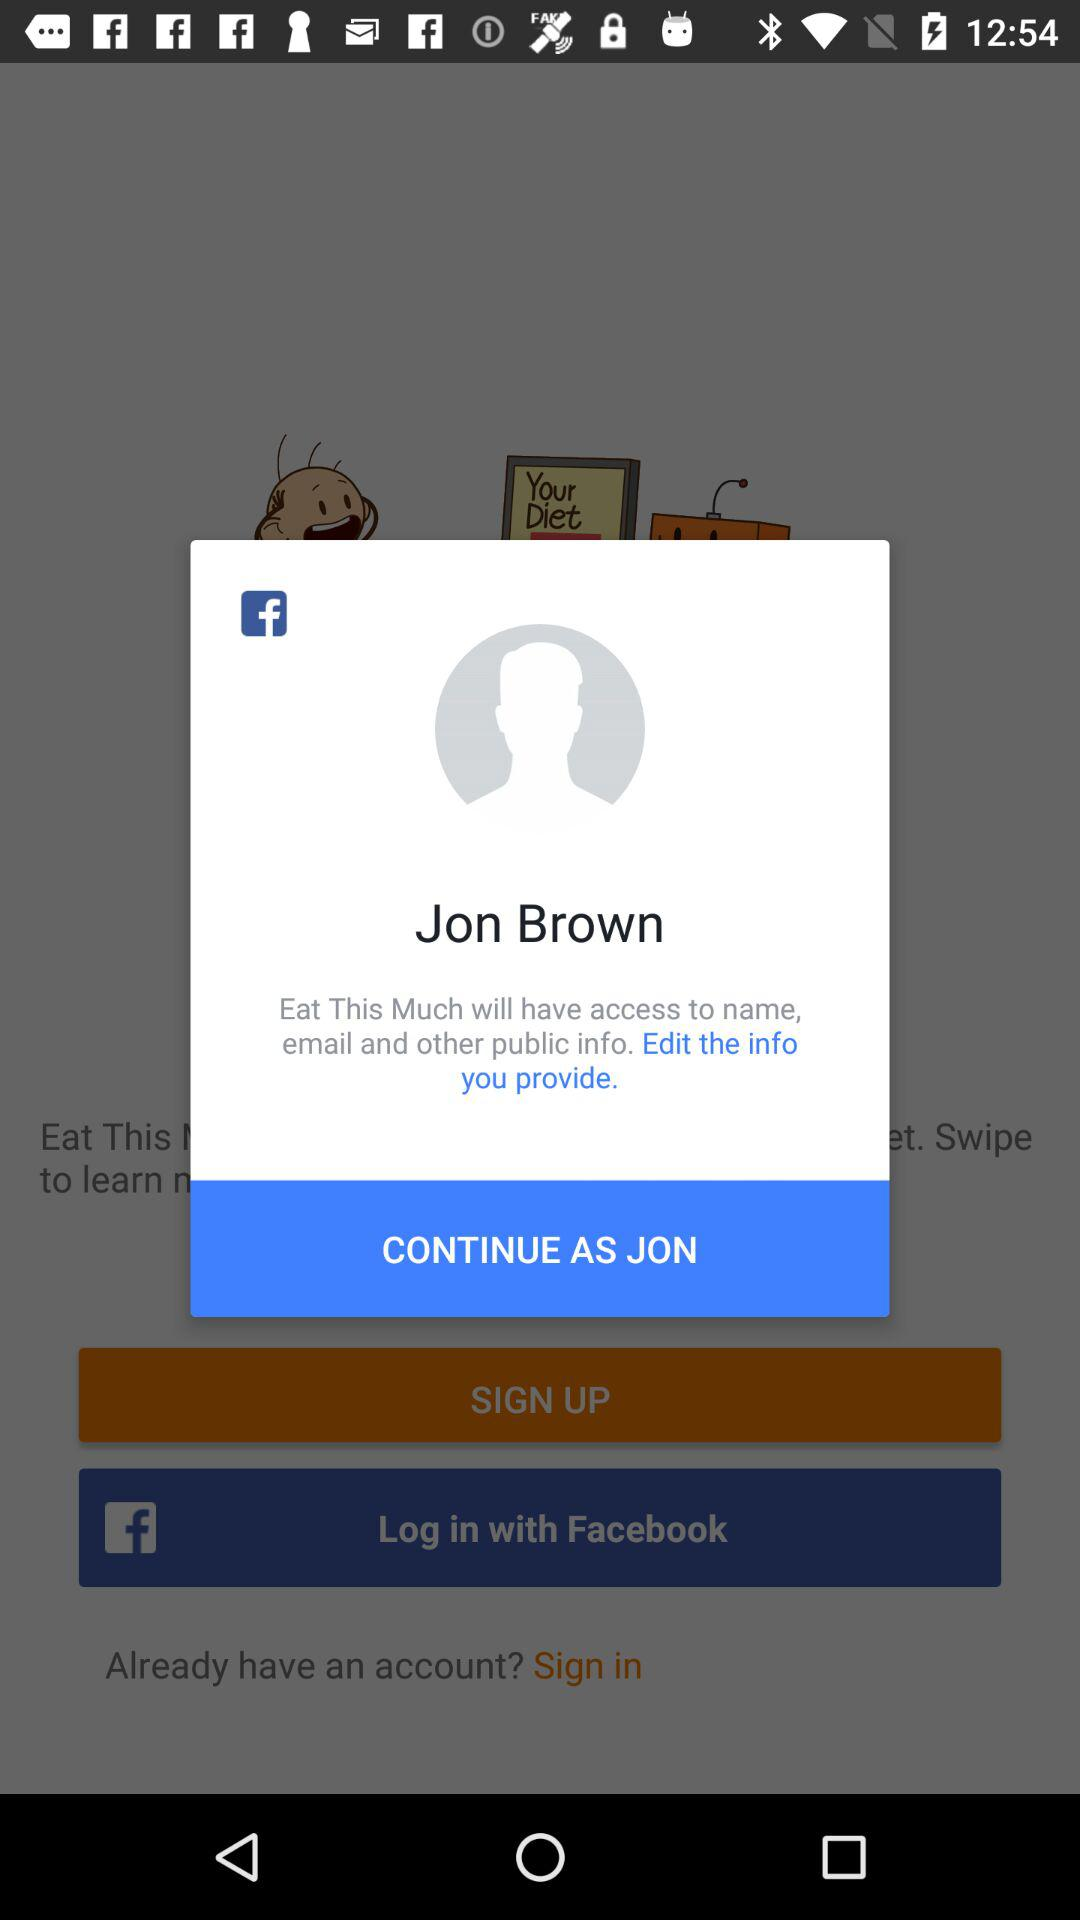What application is asking for permission? The application asking for permission is "Eat This Much". 